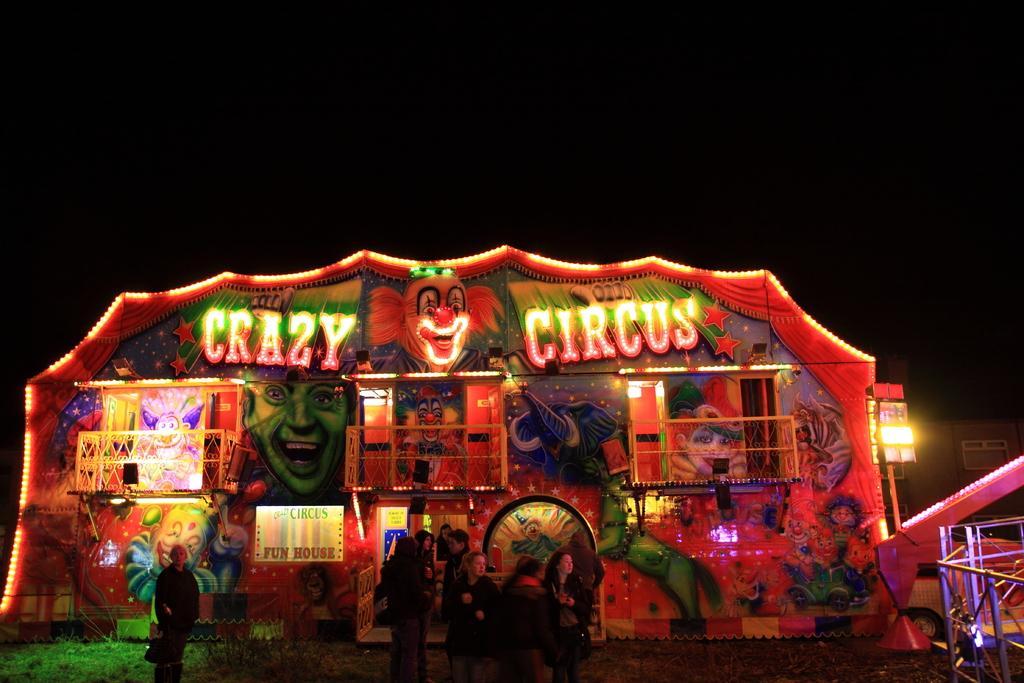In one or two sentences, can you explain what this image depicts? At the bottom of the picture, we see the group of people are standing. The man on the left side is standing. On the right side, we see the iron rods or a railing. Beside that, we see a white vehicle. In the middle of the picture, we see a building or a tent which is decorated with the lights and the posters. On top of it, it is written as "CRAZY CIRCUS". At the top, it is black in color. At the bottom, we see the grass. This picture is clicked in the dark. This picture might be clicked in the circus. 